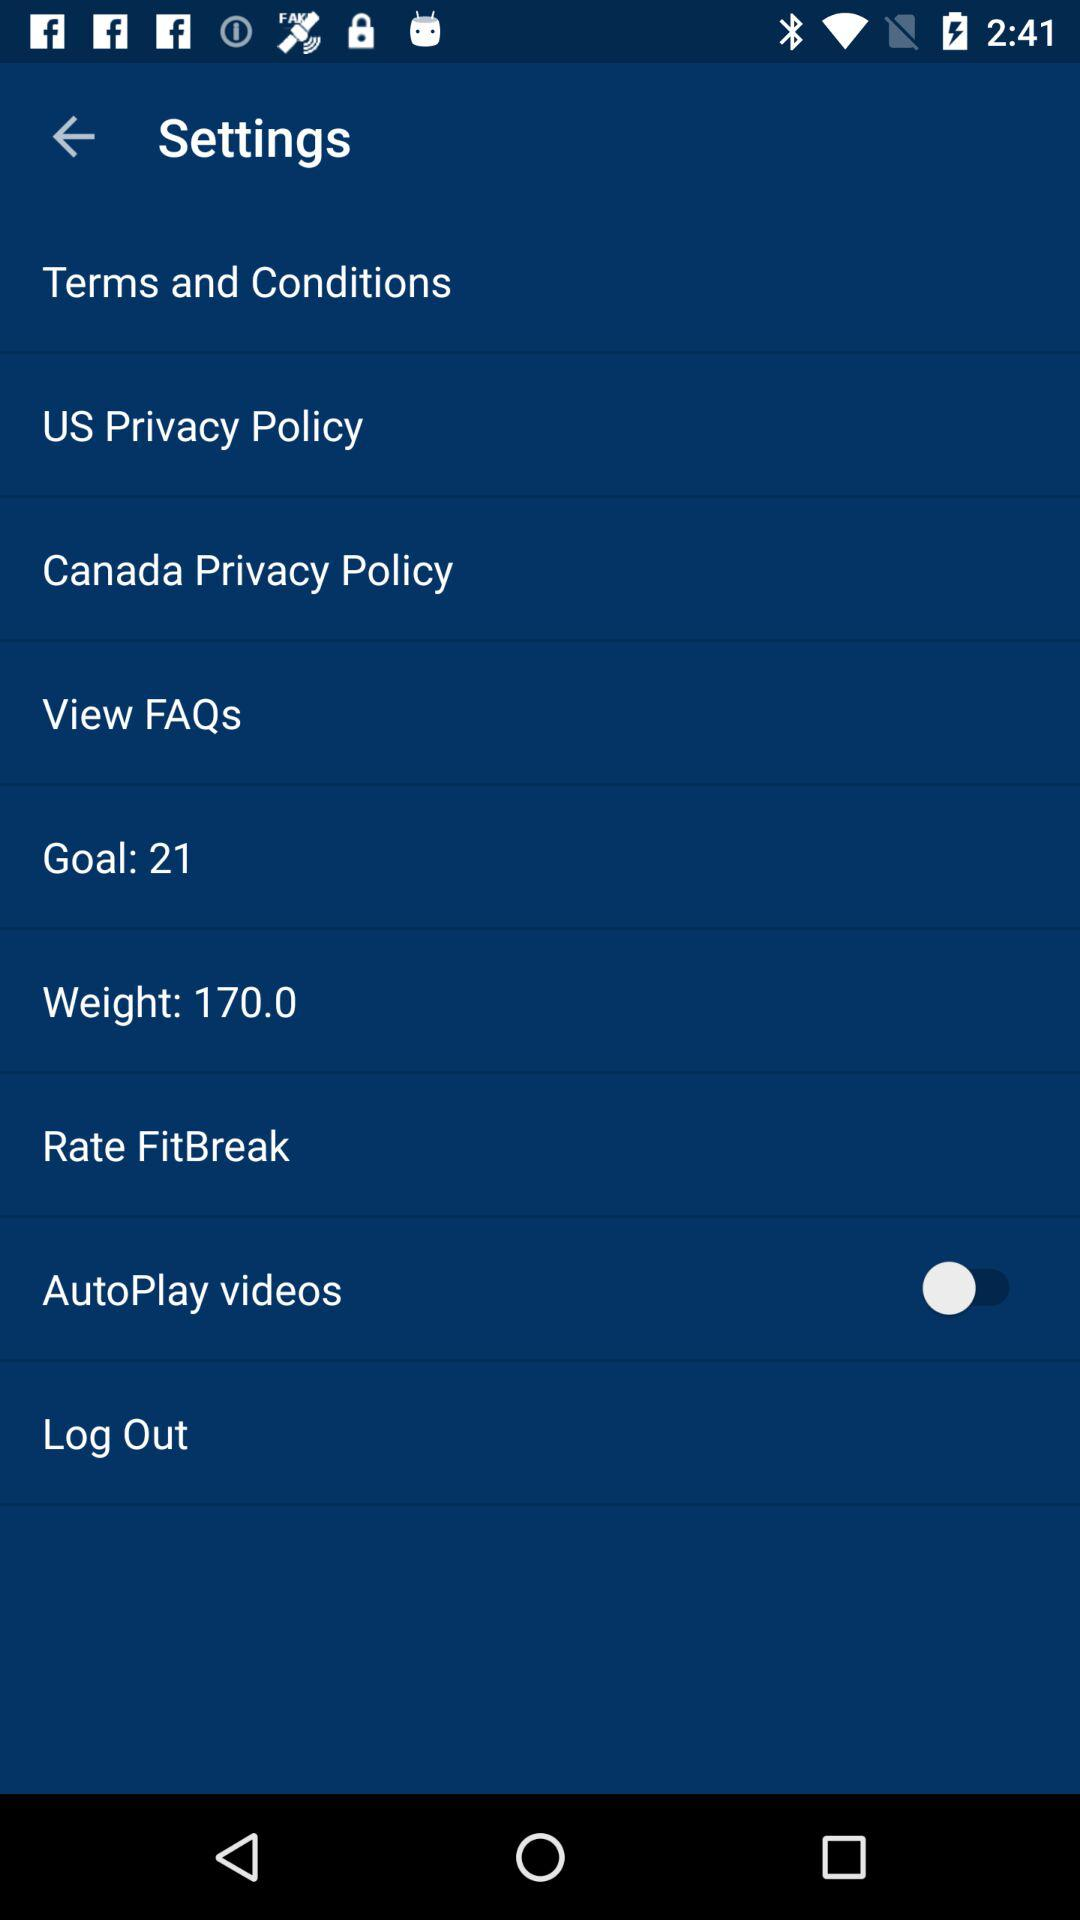What is the status of "AutoPlay videos"? The status is "off". 